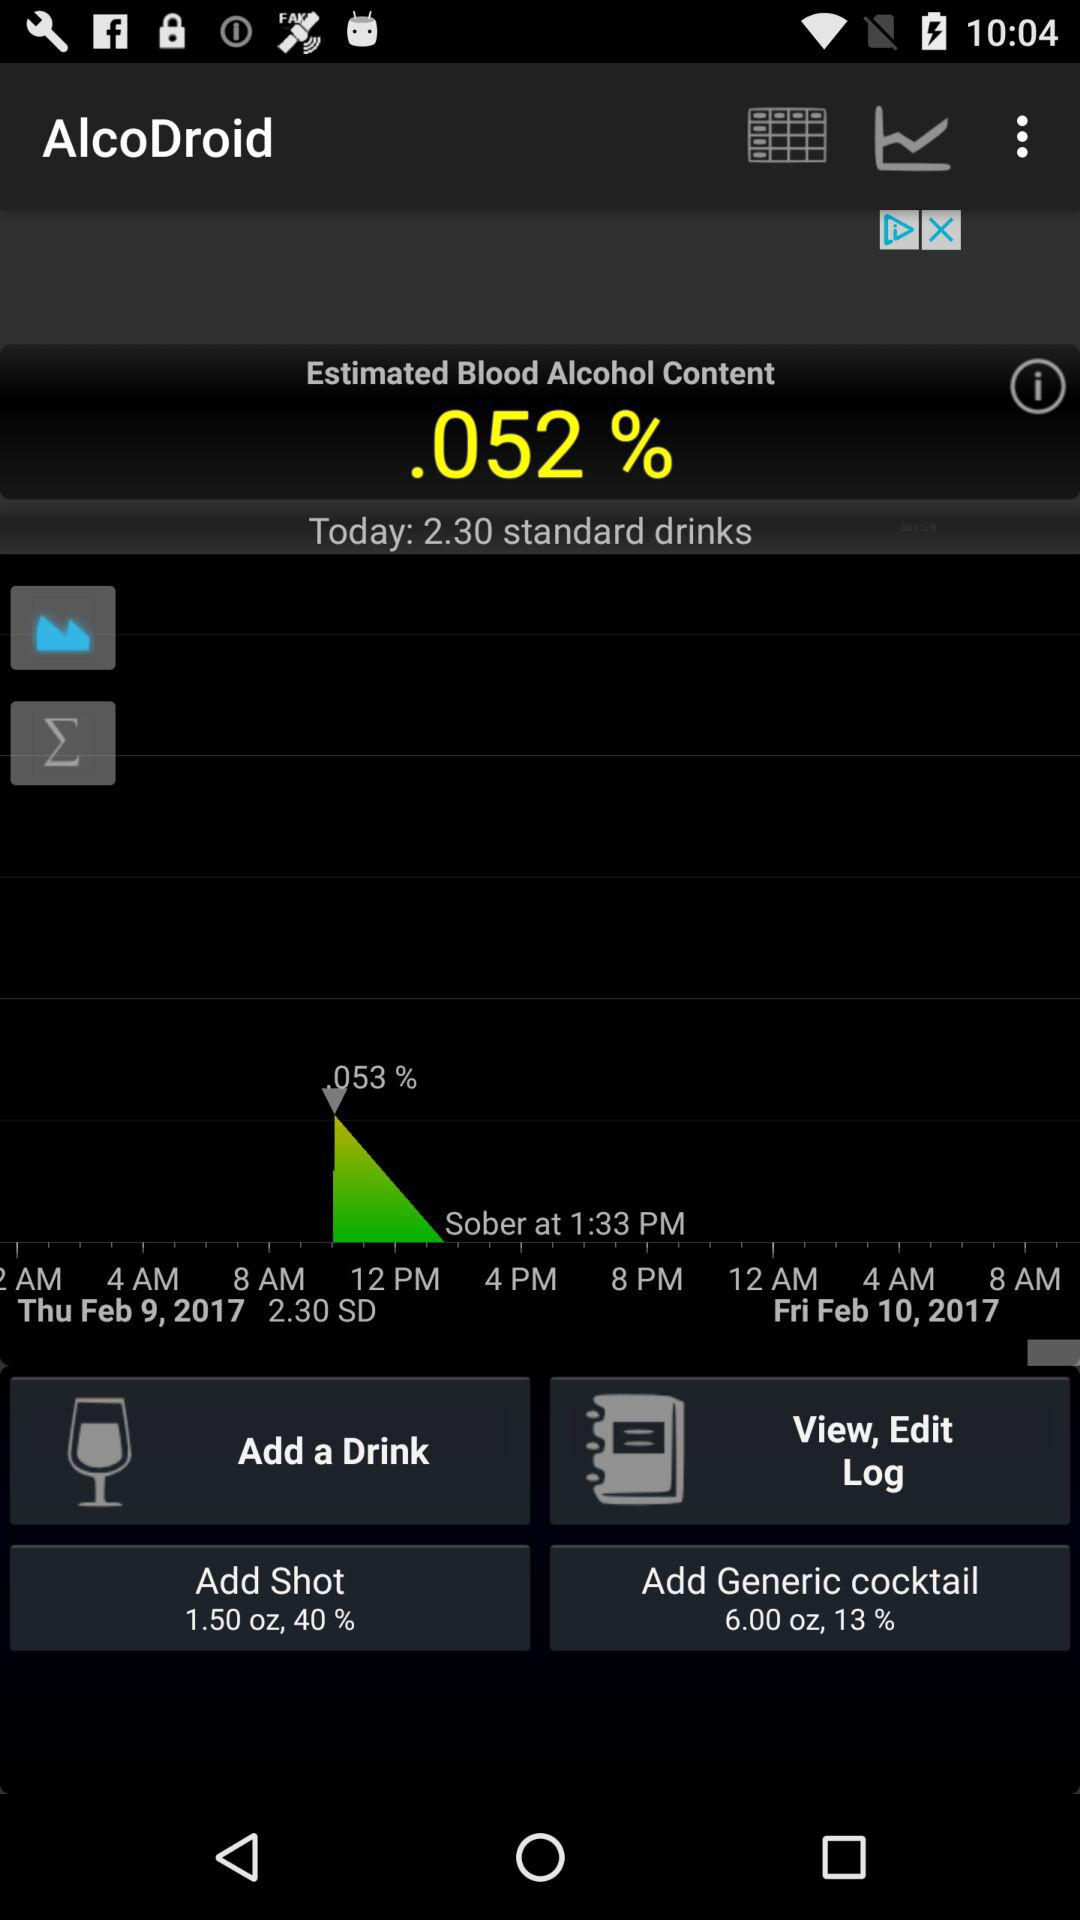What is the amount of a standard drink? The amount of a standard drink is 2.30. 